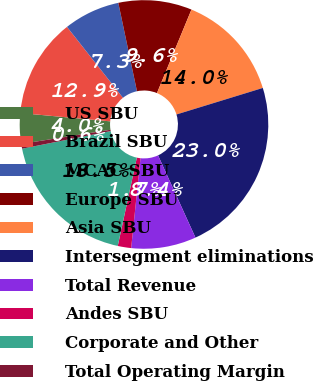Convert chart to OTSL. <chart><loc_0><loc_0><loc_500><loc_500><pie_chart><fcel>US SBU<fcel>Brazil SBU<fcel>MCAC SBU<fcel>Europe SBU<fcel>Asia SBU<fcel>Intersegment eliminations<fcel>Total Revenue<fcel>Andes SBU<fcel>Corporate and Other<fcel>Total Operating Margin<nl><fcel>3.97%<fcel>12.9%<fcel>7.32%<fcel>9.55%<fcel>14.02%<fcel>22.95%<fcel>8.44%<fcel>1.74%<fcel>18.49%<fcel>0.62%<nl></chart> 